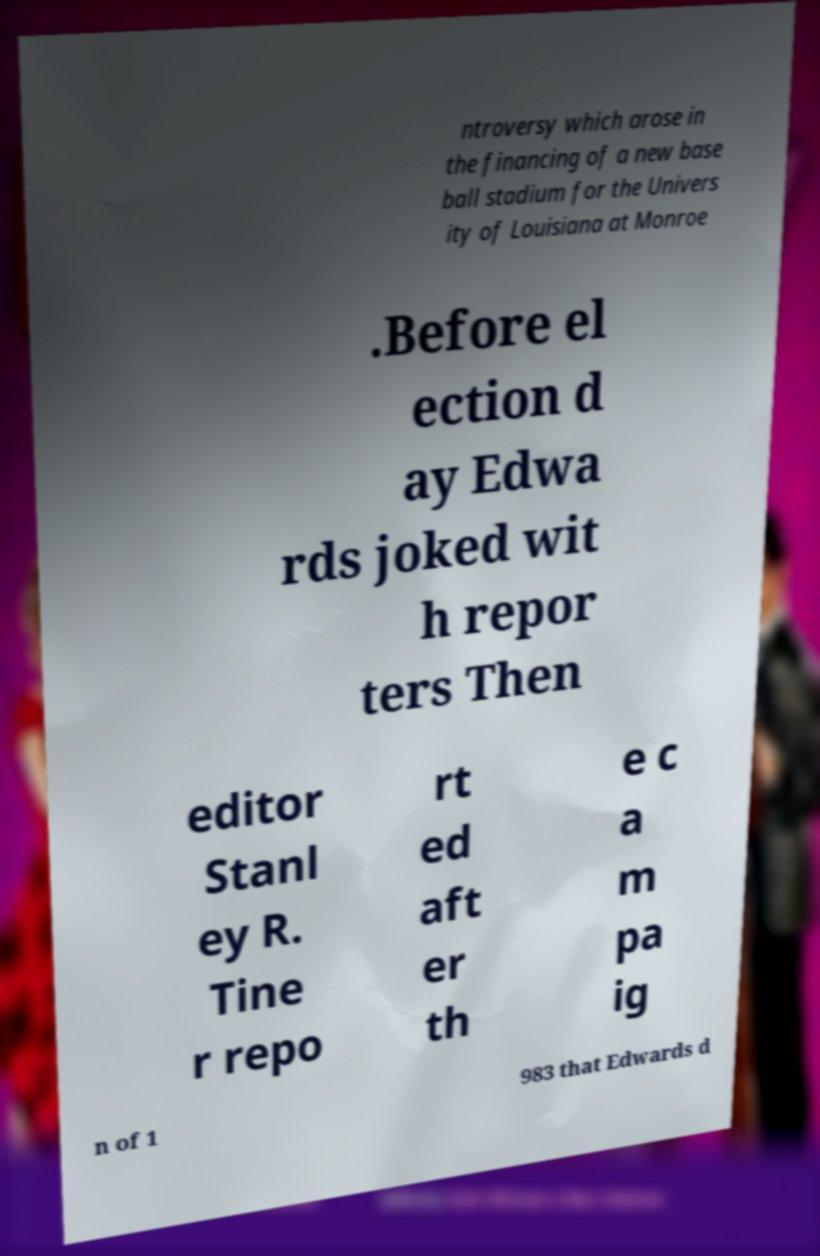What messages or text are displayed in this image? I need them in a readable, typed format. ntroversy which arose in the financing of a new base ball stadium for the Univers ity of Louisiana at Monroe .Before el ection d ay Edwa rds joked wit h repor ters Then editor Stanl ey R. Tine r repo rt ed aft er th e c a m pa ig n of 1 983 that Edwards d 